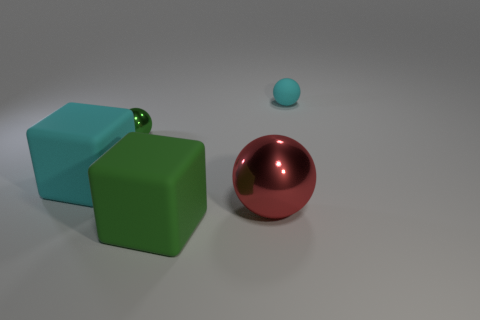Is there any indication of what these objects could be used for? The objects in the image, a cube, a sphere, and a smaller ball, appear to be generic geometric shapes without any specific features that would suggest a practical use. They might represent basic shapes used for educational or design purposes, or perhaps they're part of a larger abstract art installation. 